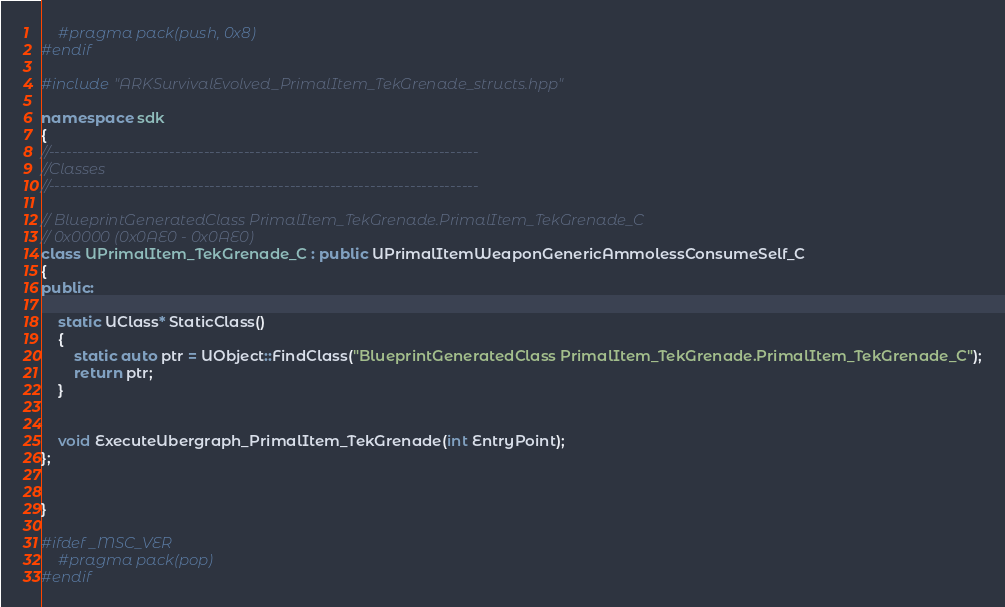<code> <loc_0><loc_0><loc_500><loc_500><_C++_>	#pragma pack(push, 0x8)
#endif

#include "ARKSurvivalEvolved_PrimalItem_TekGrenade_structs.hpp"

namespace sdk
{
//---------------------------------------------------------------------------
//Classes
//---------------------------------------------------------------------------

// BlueprintGeneratedClass PrimalItem_TekGrenade.PrimalItem_TekGrenade_C
// 0x0000 (0x0AE0 - 0x0AE0)
class UPrimalItem_TekGrenade_C : public UPrimalItemWeaponGenericAmmolessConsumeSelf_C
{
public:

	static UClass* StaticClass()
	{
		static auto ptr = UObject::FindClass("BlueprintGeneratedClass PrimalItem_TekGrenade.PrimalItem_TekGrenade_C");
		return ptr;
	}


	void ExecuteUbergraph_PrimalItem_TekGrenade(int EntryPoint);
};


}

#ifdef _MSC_VER
	#pragma pack(pop)
#endif
</code> 